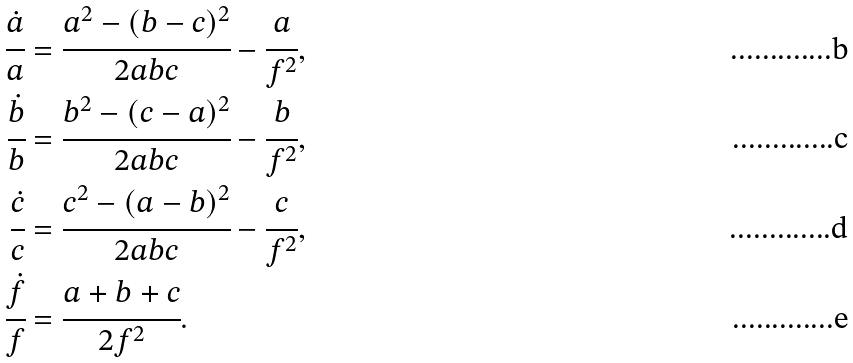Convert formula to latex. <formula><loc_0><loc_0><loc_500><loc_500>\cfrac { \dot { a } } { a } & = \cfrac { a ^ { 2 } - ( b - c ) ^ { 2 } } { 2 a b c } - \cfrac { a } { f ^ { 2 } } , \\ \cfrac { \dot { b } } { b } & = \cfrac { b ^ { 2 } - ( c - a ) ^ { 2 } } { 2 a b c } - \cfrac { b } { f ^ { 2 } } , \\ \cfrac { \dot { c } } { c } & = \cfrac { c ^ { 2 } - ( a - b ) ^ { 2 } } { 2 a b c } - \cfrac { c } { f ^ { 2 } } , \\ \cfrac { \dot { f } } { f } & = \cfrac { a + b + c } { 2 f ^ { 2 } } .</formula> 